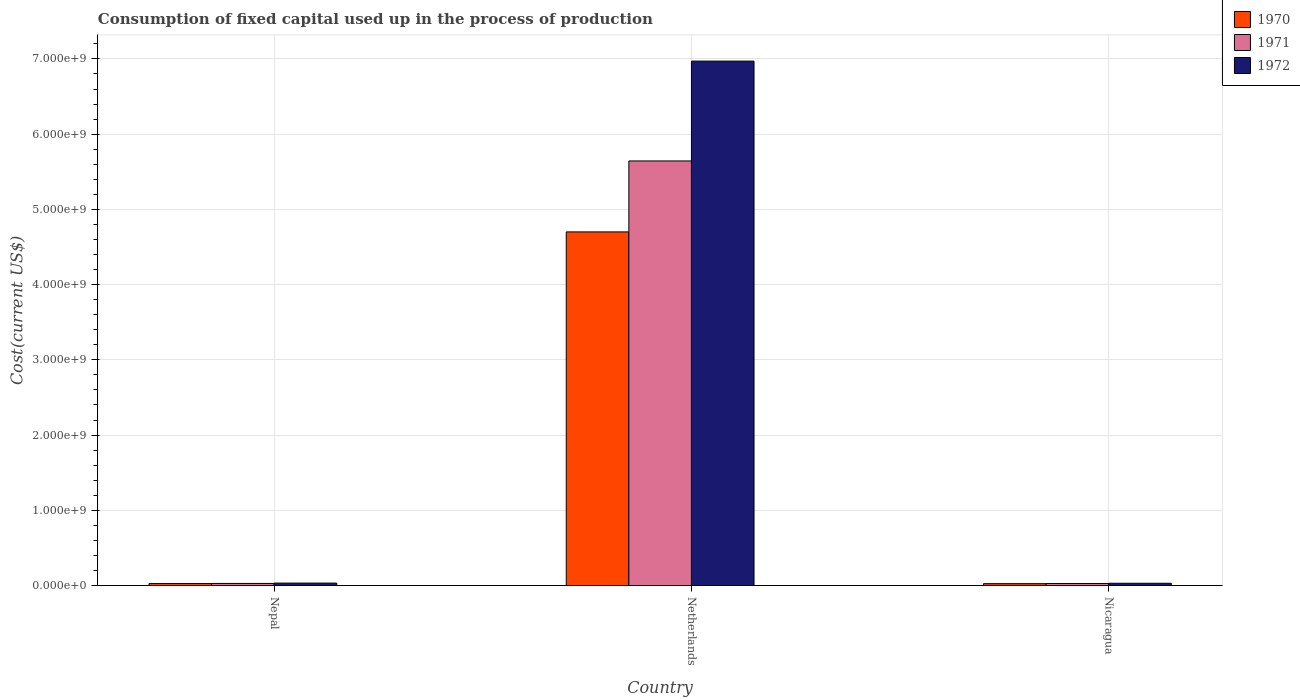How many different coloured bars are there?
Provide a short and direct response. 3. How many groups of bars are there?
Your response must be concise. 3. Are the number of bars per tick equal to the number of legend labels?
Your answer should be very brief. Yes. How many bars are there on the 3rd tick from the left?
Ensure brevity in your answer.  3. How many bars are there on the 3rd tick from the right?
Your answer should be compact. 3. What is the label of the 2nd group of bars from the left?
Ensure brevity in your answer.  Netherlands. In how many cases, is the number of bars for a given country not equal to the number of legend labels?
Your answer should be very brief. 0. What is the amount consumed in the process of production in 1970 in Nepal?
Your answer should be very brief. 2.69e+07. Across all countries, what is the maximum amount consumed in the process of production in 1972?
Keep it short and to the point. 6.97e+09. Across all countries, what is the minimum amount consumed in the process of production in 1972?
Give a very brief answer. 3.05e+07. In which country was the amount consumed in the process of production in 1971 maximum?
Your response must be concise. Netherlands. In which country was the amount consumed in the process of production in 1972 minimum?
Make the answer very short. Nicaragua. What is the total amount consumed in the process of production in 1971 in the graph?
Offer a very short reply. 5.70e+09. What is the difference between the amount consumed in the process of production in 1971 in Nepal and that in Netherlands?
Provide a short and direct response. -5.62e+09. What is the difference between the amount consumed in the process of production in 1970 in Nepal and the amount consumed in the process of production in 1971 in Netherlands?
Ensure brevity in your answer.  -5.62e+09. What is the average amount consumed in the process of production in 1971 per country?
Your response must be concise. 1.90e+09. What is the difference between the amount consumed in the process of production of/in 1970 and amount consumed in the process of production of/in 1971 in Nepal?
Ensure brevity in your answer.  -1.24e+06. What is the ratio of the amount consumed in the process of production in 1971 in Nepal to that in Netherlands?
Give a very brief answer. 0. Is the amount consumed in the process of production in 1972 in Nepal less than that in Nicaragua?
Ensure brevity in your answer.  No. What is the difference between the highest and the second highest amount consumed in the process of production in 1971?
Your answer should be very brief. -9.84e+05. What is the difference between the highest and the lowest amount consumed in the process of production in 1971?
Your response must be concise. 5.62e+09. Is the sum of the amount consumed in the process of production in 1970 in Nepal and Nicaragua greater than the maximum amount consumed in the process of production in 1971 across all countries?
Ensure brevity in your answer.  No. What does the 2nd bar from the left in Nepal represents?
Provide a short and direct response. 1971. What does the 2nd bar from the right in Nepal represents?
Ensure brevity in your answer.  1971. How many bars are there?
Provide a succinct answer. 9. Are all the bars in the graph horizontal?
Offer a very short reply. No. Does the graph contain grids?
Provide a short and direct response. Yes. How many legend labels are there?
Your answer should be very brief. 3. What is the title of the graph?
Your response must be concise. Consumption of fixed capital used up in the process of production. What is the label or title of the X-axis?
Make the answer very short. Country. What is the label or title of the Y-axis?
Offer a very short reply. Cost(current US$). What is the Cost(current US$) of 1970 in Nepal?
Provide a short and direct response. 2.69e+07. What is the Cost(current US$) of 1971 in Nepal?
Ensure brevity in your answer.  2.81e+07. What is the Cost(current US$) in 1972 in Nepal?
Give a very brief answer. 3.28e+07. What is the Cost(current US$) of 1970 in Netherlands?
Offer a very short reply. 4.70e+09. What is the Cost(current US$) of 1971 in Netherlands?
Provide a succinct answer. 5.64e+09. What is the Cost(current US$) of 1972 in Netherlands?
Keep it short and to the point. 6.97e+09. What is the Cost(current US$) in 1970 in Nicaragua?
Your answer should be compact. 2.53e+07. What is the Cost(current US$) in 1971 in Nicaragua?
Provide a succinct answer. 2.71e+07. What is the Cost(current US$) of 1972 in Nicaragua?
Offer a terse response. 3.05e+07. Across all countries, what is the maximum Cost(current US$) of 1970?
Offer a very short reply. 4.70e+09. Across all countries, what is the maximum Cost(current US$) of 1971?
Offer a very short reply. 5.64e+09. Across all countries, what is the maximum Cost(current US$) of 1972?
Provide a succinct answer. 6.97e+09. Across all countries, what is the minimum Cost(current US$) in 1970?
Give a very brief answer. 2.53e+07. Across all countries, what is the minimum Cost(current US$) of 1971?
Make the answer very short. 2.71e+07. Across all countries, what is the minimum Cost(current US$) of 1972?
Give a very brief answer. 3.05e+07. What is the total Cost(current US$) of 1970 in the graph?
Give a very brief answer. 4.75e+09. What is the total Cost(current US$) in 1971 in the graph?
Make the answer very short. 5.70e+09. What is the total Cost(current US$) of 1972 in the graph?
Your answer should be compact. 7.03e+09. What is the difference between the Cost(current US$) of 1970 in Nepal and that in Netherlands?
Provide a short and direct response. -4.67e+09. What is the difference between the Cost(current US$) in 1971 in Nepal and that in Netherlands?
Provide a short and direct response. -5.62e+09. What is the difference between the Cost(current US$) of 1972 in Nepal and that in Netherlands?
Make the answer very short. -6.94e+09. What is the difference between the Cost(current US$) of 1970 in Nepal and that in Nicaragua?
Keep it short and to the point. 1.59e+06. What is the difference between the Cost(current US$) of 1971 in Nepal and that in Nicaragua?
Provide a short and direct response. 9.84e+05. What is the difference between the Cost(current US$) in 1972 in Nepal and that in Nicaragua?
Ensure brevity in your answer.  2.31e+06. What is the difference between the Cost(current US$) of 1970 in Netherlands and that in Nicaragua?
Give a very brief answer. 4.68e+09. What is the difference between the Cost(current US$) of 1971 in Netherlands and that in Nicaragua?
Give a very brief answer. 5.62e+09. What is the difference between the Cost(current US$) in 1972 in Netherlands and that in Nicaragua?
Offer a terse response. 6.94e+09. What is the difference between the Cost(current US$) in 1970 in Nepal and the Cost(current US$) in 1971 in Netherlands?
Keep it short and to the point. -5.62e+09. What is the difference between the Cost(current US$) of 1970 in Nepal and the Cost(current US$) of 1972 in Netherlands?
Make the answer very short. -6.94e+09. What is the difference between the Cost(current US$) in 1971 in Nepal and the Cost(current US$) in 1972 in Netherlands?
Give a very brief answer. -6.94e+09. What is the difference between the Cost(current US$) of 1970 in Nepal and the Cost(current US$) of 1971 in Nicaragua?
Ensure brevity in your answer.  -2.55e+05. What is the difference between the Cost(current US$) in 1970 in Nepal and the Cost(current US$) in 1972 in Nicaragua?
Your response must be concise. -3.64e+06. What is the difference between the Cost(current US$) in 1971 in Nepal and the Cost(current US$) in 1972 in Nicaragua?
Make the answer very short. -2.40e+06. What is the difference between the Cost(current US$) in 1970 in Netherlands and the Cost(current US$) in 1971 in Nicaragua?
Keep it short and to the point. 4.67e+09. What is the difference between the Cost(current US$) of 1970 in Netherlands and the Cost(current US$) of 1972 in Nicaragua?
Provide a succinct answer. 4.67e+09. What is the difference between the Cost(current US$) of 1971 in Netherlands and the Cost(current US$) of 1972 in Nicaragua?
Make the answer very short. 5.61e+09. What is the average Cost(current US$) of 1970 per country?
Make the answer very short. 1.58e+09. What is the average Cost(current US$) of 1971 per country?
Offer a terse response. 1.90e+09. What is the average Cost(current US$) of 1972 per country?
Make the answer very short. 2.34e+09. What is the difference between the Cost(current US$) of 1970 and Cost(current US$) of 1971 in Nepal?
Offer a very short reply. -1.24e+06. What is the difference between the Cost(current US$) in 1970 and Cost(current US$) in 1972 in Nepal?
Make the answer very short. -5.95e+06. What is the difference between the Cost(current US$) of 1971 and Cost(current US$) of 1972 in Nepal?
Provide a succinct answer. -4.71e+06. What is the difference between the Cost(current US$) in 1970 and Cost(current US$) in 1971 in Netherlands?
Offer a very short reply. -9.43e+08. What is the difference between the Cost(current US$) of 1970 and Cost(current US$) of 1972 in Netherlands?
Keep it short and to the point. -2.27e+09. What is the difference between the Cost(current US$) of 1971 and Cost(current US$) of 1972 in Netherlands?
Make the answer very short. -1.33e+09. What is the difference between the Cost(current US$) in 1970 and Cost(current US$) in 1971 in Nicaragua?
Provide a succinct answer. -1.84e+06. What is the difference between the Cost(current US$) of 1970 and Cost(current US$) of 1972 in Nicaragua?
Make the answer very short. -5.23e+06. What is the difference between the Cost(current US$) in 1971 and Cost(current US$) in 1972 in Nicaragua?
Offer a terse response. -3.38e+06. What is the ratio of the Cost(current US$) of 1970 in Nepal to that in Netherlands?
Keep it short and to the point. 0.01. What is the ratio of the Cost(current US$) in 1971 in Nepal to that in Netherlands?
Offer a very short reply. 0.01. What is the ratio of the Cost(current US$) in 1972 in Nepal to that in Netherlands?
Provide a short and direct response. 0. What is the ratio of the Cost(current US$) in 1970 in Nepal to that in Nicaragua?
Ensure brevity in your answer.  1.06. What is the ratio of the Cost(current US$) in 1971 in Nepal to that in Nicaragua?
Your response must be concise. 1.04. What is the ratio of the Cost(current US$) of 1972 in Nepal to that in Nicaragua?
Ensure brevity in your answer.  1.08. What is the ratio of the Cost(current US$) of 1970 in Netherlands to that in Nicaragua?
Provide a short and direct response. 185.81. What is the ratio of the Cost(current US$) in 1971 in Netherlands to that in Nicaragua?
Your response must be concise. 207.94. What is the ratio of the Cost(current US$) of 1972 in Netherlands to that in Nicaragua?
Provide a short and direct response. 228.36. What is the difference between the highest and the second highest Cost(current US$) of 1970?
Your response must be concise. 4.67e+09. What is the difference between the highest and the second highest Cost(current US$) of 1971?
Offer a very short reply. 5.62e+09. What is the difference between the highest and the second highest Cost(current US$) of 1972?
Provide a short and direct response. 6.94e+09. What is the difference between the highest and the lowest Cost(current US$) of 1970?
Provide a succinct answer. 4.68e+09. What is the difference between the highest and the lowest Cost(current US$) of 1971?
Ensure brevity in your answer.  5.62e+09. What is the difference between the highest and the lowest Cost(current US$) of 1972?
Ensure brevity in your answer.  6.94e+09. 